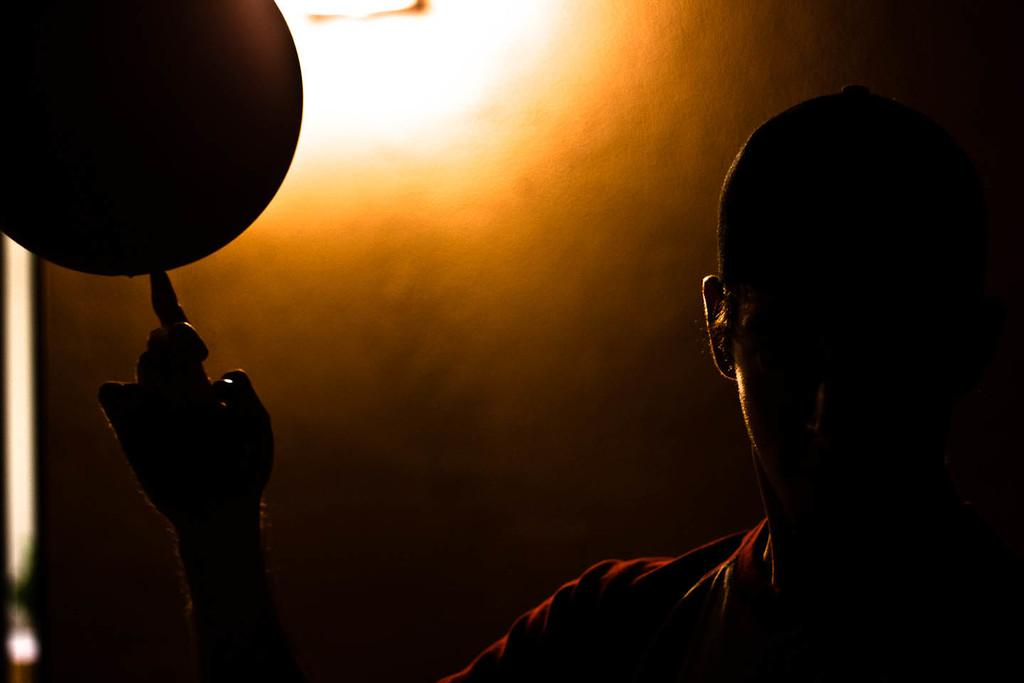What is the main subject of the image? There is a person in the image. What is the person doing in the image? The person is holding a ball on his finger. How would you describe the overall appearance of the image? The image has a dark appearance. What can be seen in the background of the image? There is a wall and a light in the background of the image. What type of mountain can be seen in the background of the image? There is no mountain present in the image; it only features a wall and a light in the background. Who is the creator of the ball being held by the person in the image? The facts provided do not mention the creator of the ball, so it cannot be determined from the image. 